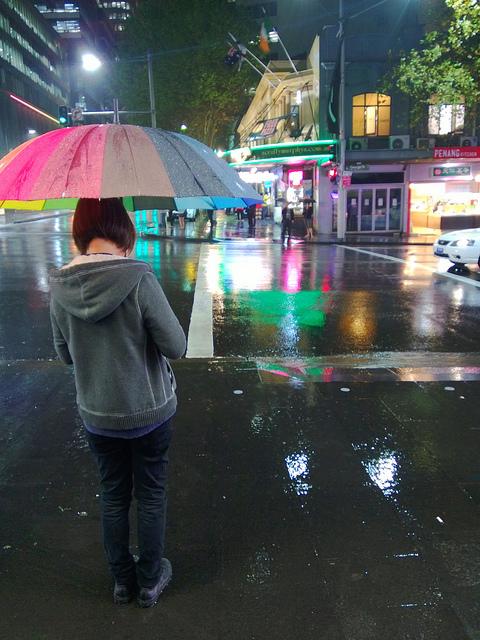Is the sun visible in this picture?
Be succinct. No. IS it raining?
Write a very short answer. Yes. What color is the umbrella?
Write a very short answer. Multi-colored. 